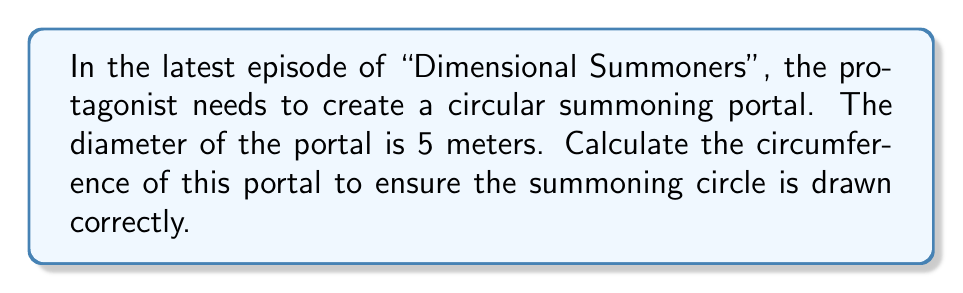Show me your answer to this math problem. To find the circumference of a circular summoning portal, we need to use the formula for the circumference of a circle:

$$C = \pi d$$

Where:
$C$ = circumference
$\pi$ = pi (approximately 3.14159)
$d$ = diameter

Given:
- Diameter $(d) = 5$ meters

Step 1: Substitute the known values into the formula.
$$C = \pi \cdot 5$$

Step 2: Multiply $\pi$ by 5.
$$C = 5\pi$$

Step 3: For a more precise numerical value, we can use 3.14159 as an approximation for $\pi$.
$$C \approx 5 \cdot 3.14159 = 15.70795 \text{ meters}$$

[asy]
import geometry;

size(100);
draw(circle((0,0), 2.5), blue);
draw((-2.5,0)--(2.5,0), red, Arrow);
label("5 m", (0,-0.5), S);
label("C = 5π m", (0,3), N);
[/asy]

The circumference of the summoning portal is $5\pi$ meters, or approximately 15.70795 meters.
Answer: $5\pi$ meters 